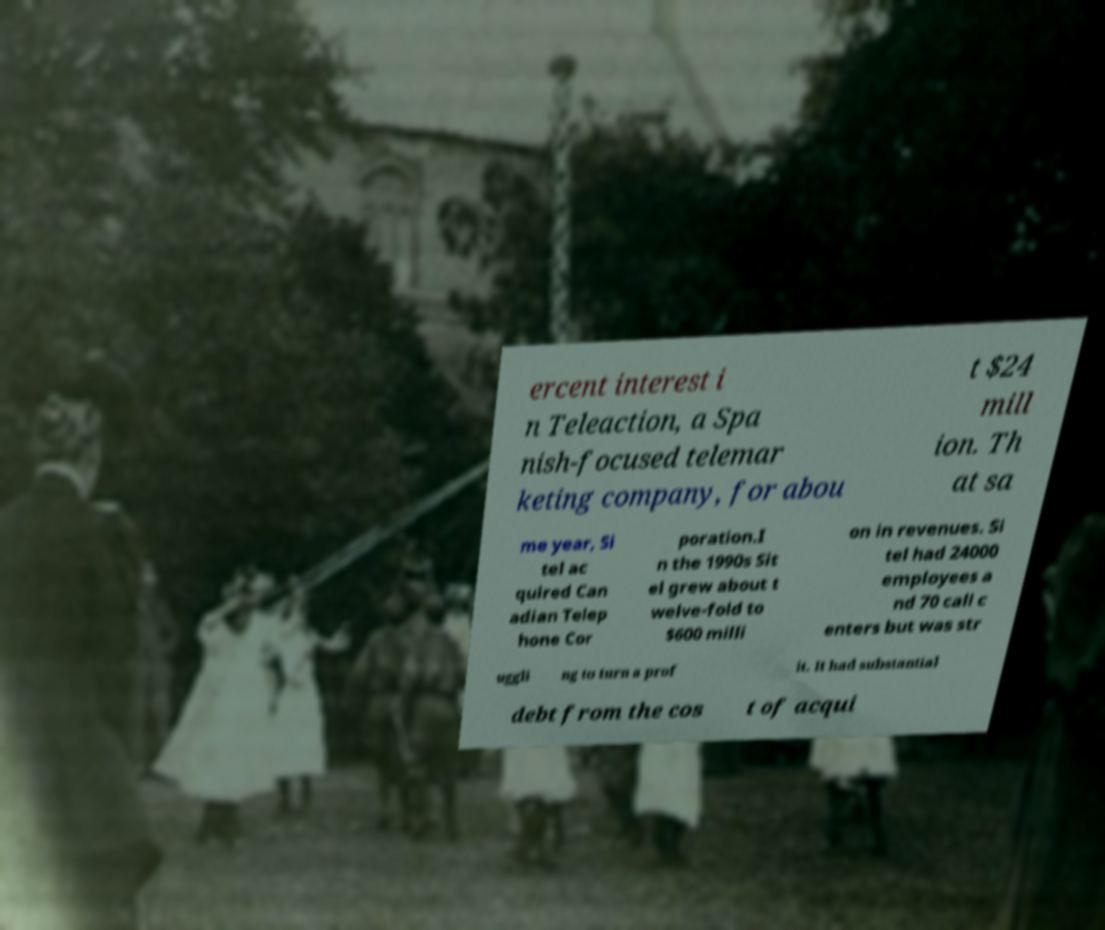Please identify and transcribe the text found in this image. ercent interest i n Teleaction, a Spa nish-focused telemar keting company, for abou t $24 mill ion. Th at sa me year, Si tel ac quired Can adian Telep hone Cor poration.I n the 1990s Sit el grew about t welve-fold to $600 milli on in revenues. Si tel had 24000 employees a nd 70 call c enters but was str uggli ng to turn a prof it. It had substantial debt from the cos t of acqui 